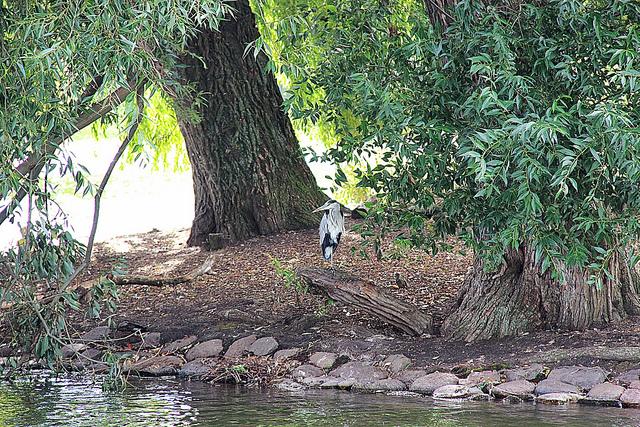Is that dirty water?
Keep it brief. No. What are the birds doing?
Give a very brief answer. Standing. Where is the bird in the picture?
Short answer required. On log. Are the leaves green?
Answer briefly. Yes. What is lining the shore?
Short answer required. Rocks. What kind of bird is this?
Give a very brief answer. Crane. 